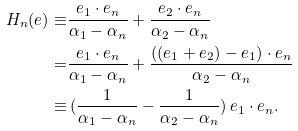<formula> <loc_0><loc_0><loc_500><loc_500>H _ { n } ( e ) \equiv & \frac { e _ { 1 } \cdot e _ { n } } { \alpha _ { 1 } - \alpha _ { n } } + \frac { e _ { 2 } \cdot e _ { n } } { \alpha _ { 2 } - \alpha _ { n } } \\ = & \frac { e _ { 1 } \cdot e _ { n } } { \alpha _ { 1 } - \alpha _ { n } } + \frac { ( ( e _ { 1 } + e _ { 2 } ) - e _ { 1 } ) \cdot e _ { n } } { \alpha _ { 2 } - \alpha _ { n } } \\ \equiv & \ ( \frac { 1 } { \alpha _ { 1 } - \alpha _ { n } } - \frac { 1 } { \alpha _ { 2 } - \alpha _ { n } } ) \ e _ { 1 } \cdot e _ { n } .</formula> 